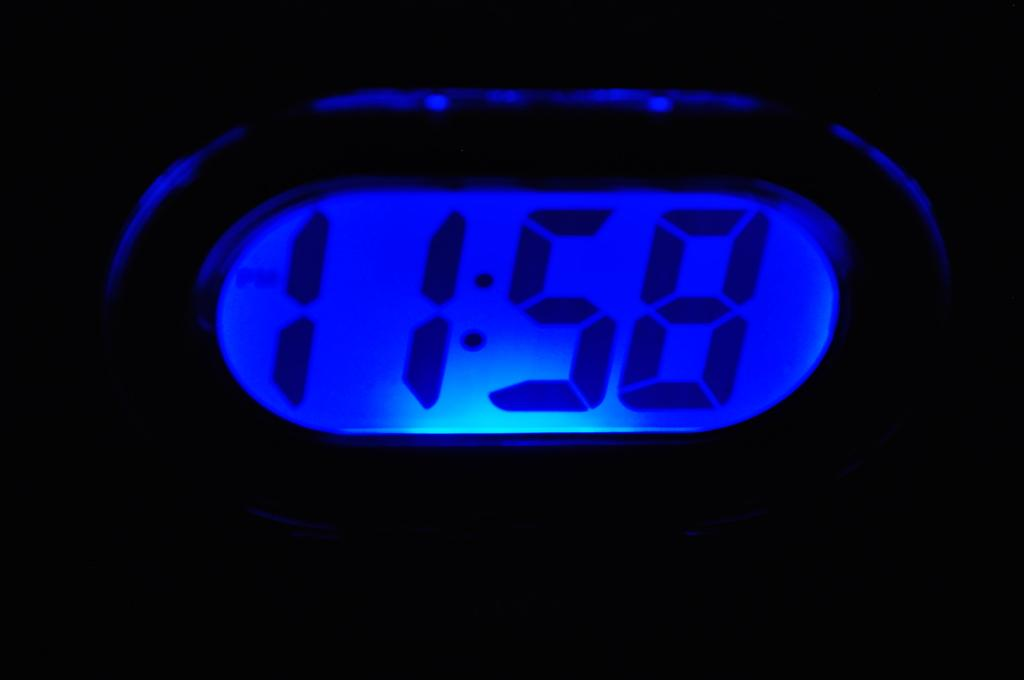What is the main object in the image? There is a digital meter in the image. What can be said about the color of the digital meter? The digital meter is blue in color. Where is the kettle located in the image? There is no kettle present in the image. What type of dock can be seen near the digital meter in the image? There is no dock present in the image. 